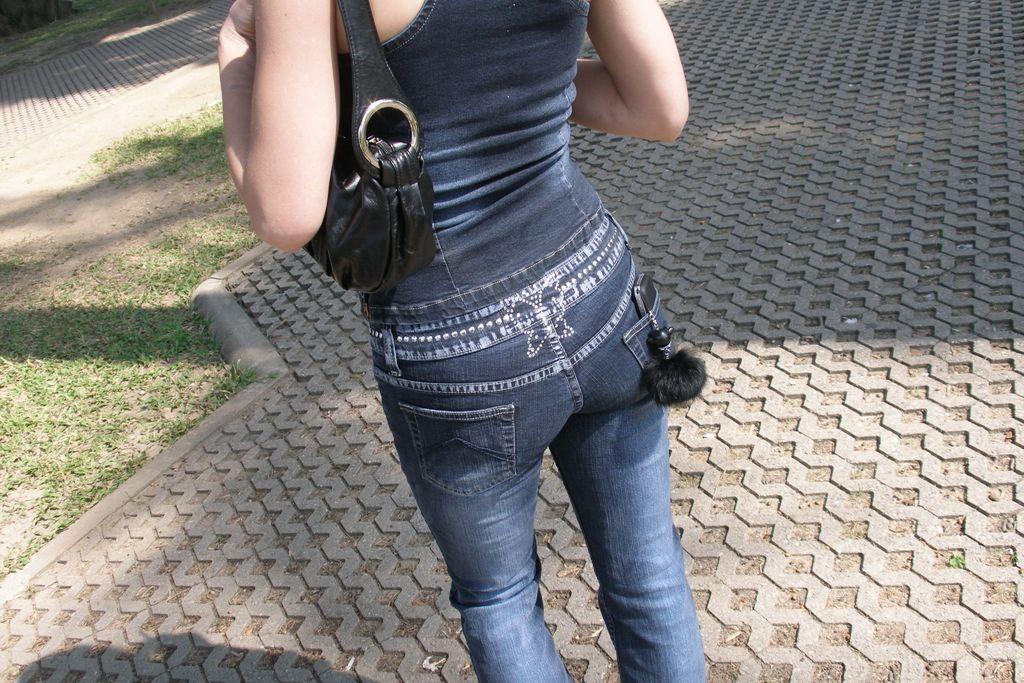Can you describe this image briefly? In this image we can see a woman is standing on the pavement. She is wearing dark blue color top, jeans and carrying black color bag. We can see some grass on the land. 